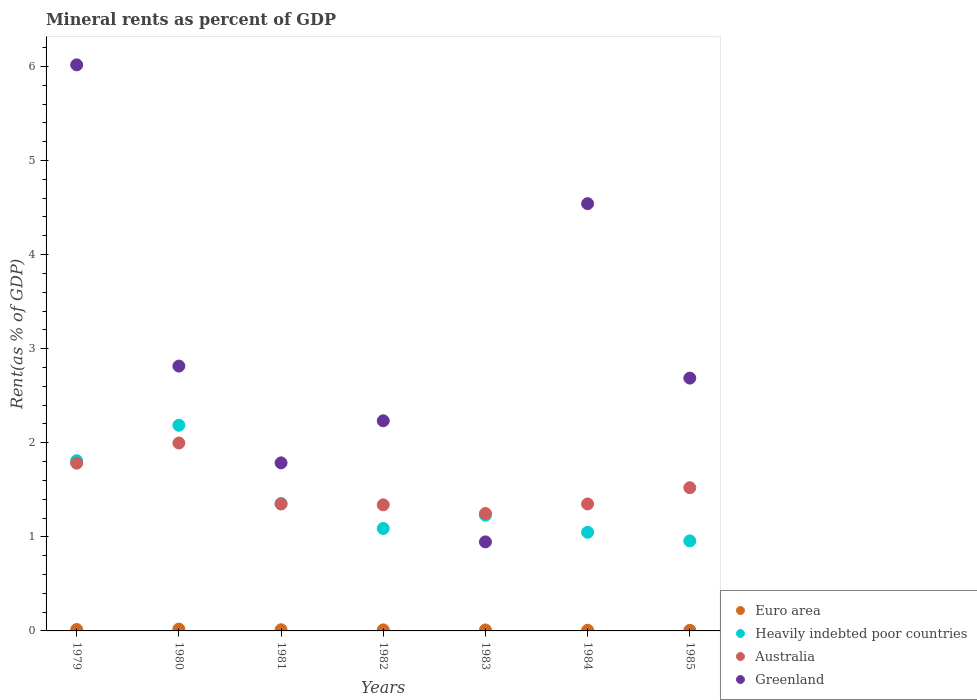How many different coloured dotlines are there?
Your answer should be very brief. 4. What is the mineral rent in Heavily indebted poor countries in 1983?
Your answer should be very brief. 1.23. Across all years, what is the maximum mineral rent in Greenland?
Offer a very short reply. 6.02. Across all years, what is the minimum mineral rent in Australia?
Make the answer very short. 1.25. In which year was the mineral rent in Australia maximum?
Make the answer very short. 1980. In which year was the mineral rent in Australia minimum?
Provide a short and direct response. 1983. What is the total mineral rent in Euro area in the graph?
Offer a very short reply. 0.08. What is the difference between the mineral rent in Heavily indebted poor countries in 1982 and that in 1985?
Ensure brevity in your answer.  0.13. What is the difference between the mineral rent in Greenland in 1983 and the mineral rent in Australia in 1980?
Offer a very short reply. -1.05. What is the average mineral rent in Heavily indebted poor countries per year?
Offer a very short reply. 1.38. In the year 1983, what is the difference between the mineral rent in Heavily indebted poor countries and mineral rent in Euro area?
Offer a very short reply. 1.22. In how many years, is the mineral rent in Heavily indebted poor countries greater than 5.4 %?
Provide a short and direct response. 0. What is the ratio of the mineral rent in Euro area in 1979 to that in 1981?
Offer a very short reply. 1.25. Is the difference between the mineral rent in Heavily indebted poor countries in 1984 and 1985 greater than the difference between the mineral rent in Euro area in 1984 and 1985?
Give a very brief answer. Yes. What is the difference between the highest and the second highest mineral rent in Greenland?
Offer a very short reply. 1.48. What is the difference between the highest and the lowest mineral rent in Australia?
Give a very brief answer. 0.75. In how many years, is the mineral rent in Australia greater than the average mineral rent in Australia taken over all years?
Keep it short and to the point. 3. Is it the case that in every year, the sum of the mineral rent in Australia and mineral rent in Greenland  is greater than the sum of mineral rent in Heavily indebted poor countries and mineral rent in Euro area?
Provide a short and direct response. Yes. Is it the case that in every year, the sum of the mineral rent in Australia and mineral rent in Euro area  is greater than the mineral rent in Greenland?
Make the answer very short. No. Is the mineral rent in Australia strictly greater than the mineral rent in Euro area over the years?
Provide a succinct answer. Yes. How many years are there in the graph?
Offer a terse response. 7. What is the difference between two consecutive major ticks on the Y-axis?
Your answer should be compact. 1. Does the graph contain any zero values?
Ensure brevity in your answer.  No. What is the title of the graph?
Provide a succinct answer. Mineral rents as percent of GDP. What is the label or title of the Y-axis?
Offer a very short reply. Rent(as % of GDP). What is the Rent(as % of GDP) in Euro area in 1979?
Your response must be concise. 0.02. What is the Rent(as % of GDP) in Heavily indebted poor countries in 1979?
Ensure brevity in your answer.  1.81. What is the Rent(as % of GDP) in Australia in 1979?
Your answer should be compact. 1.78. What is the Rent(as % of GDP) in Greenland in 1979?
Offer a very short reply. 6.02. What is the Rent(as % of GDP) in Euro area in 1980?
Provide a short and direct response. 0.02. What is the Rent(as % of GDP) in Heavily indebted poor countries in 1980?
Offer a very short reply. 2.19. What is the Rent(as % of GDP) of Australia in 1980?
Offer a terse response. 2. What is the Rent(as % of GDP) in Greenland in 1980?
Provide a succinct answer. 2.81. What is the Rent(as % of GDP) of Euro area in 1981?
Give a very brief answer. 0.01. What is the Rent(as % of GDP) in Heavily indebted poor countries in 1981?
Provide a short and direct response. 1.35. What is the Rent(as % of GDP) in Australia in 1981?
Provide a short and direct response. 1.35. What is the Rent(as % of GDP) in Greenland in 1981?
Your answer should be very brief. 1.79. What is the Rent(as % of GDP) of Euro area in 1982?
Your answer should be compact. 0.01. What is the Rent(as % of GDP) of Heavily indebted poor countries in 1982?
Your response must be concise. 1.09. What is the Rent(as % of GDP) in Australia in 1982?
Your answer should be very brief. 1.34. What is the Rent(as % of GDP) of Greenland in 1982?
Keep it short and to the point. 2.23. What is the Rent(as % of GDP) of Euro area in 1983?
Your answer should be compact. 0.01. What is the Rent(as % of GDP) in Heavily indebted poor countries in 1983?
Provide a succinct answer. 1.23. What is the Rent(as % of GDP) in Australia in 1983?
Make the answer very short. 1.25. What is the Rent(as % of GDP) of Greenland in 1983?
Offer a terse response. 0.95. What is the Rent(as % of GDP) of Euro area in 1984?
Give a very brief answer. 0.01. What is the Rent(as % of GDP) of Heavily indebted poor countries in 1984?
Make the answer very short. 1.05. What is the Rent(as % of GDP) of Australia in 1984?
Your answer should be compact. 1.35. What is the Rent(as % of GDP) in Greenland in 1984?
Your answer should be compact. 4.54. What is the Rent(as % of GDP) of Euro area in 1985?
Make the answer very short. 0.01. What is the Rent(as % of GDP) of Heavily indebted poor countries in 1985?
Your answer should be compact. 0.96. What is the Rent(as % of GDP) of Australia in 1985?
Make the answer very short. 1.52. What is the Rent(as % of GDP) in Greenland in 1985?
Provide a short and direct response. 2.69. Across all years, what is the maximum Rent(as % of GDP) of Euro area?
Give a very brief answer. 0.02. Across all years, what is the maximum Rent(as % of GDP) in Heavily indebted poor countries?
Make the answer very short. 2.19. Across all years, what is the maximum Rent(as % of GDP) of Australia?
Give a very brief answer. 2. Across all years, what is the maximum Rent(as % of GDP) in Greenland?
Offer a very short reply. 6.02. Across all years, what is the minimum Rent(as % of GDP) in Euro area?
Provide a short and direct response. 0.01. Across all years, what is the minimum Rent(as % of GDP) in Heavily indebted poor countries?
Offer a very short reply. 0.96. Across all years, what is the minimum Rent(as % of GDP) of Australia?
Your answer should be very brief. 1.25. Across all years, what is the minimum Rent(as % of GDP) in Greenland?
Your response must be concise. 0.95. What is the total Rent(as % of GDP) in Euro area in the graph?
Keep it short and to the point. 0.08. What is the total Rent(as % of GDP) in Heavily indebted poor countries in the graph?
Your answer should be compact. 9.67. What is the total Rent(as % of GDP) in Australia in the graph?
Your answer should be compact. 10.59. What is the total Rent(as % of GDP) of Greenland in the graph?
Make the answer very short. 21.03. What is the difference between the Rent(as % of GDP) in Euro area in 1979 and that in 1980?
Offer a terse response. -0. What is the difference between the Rent(as % of GDP) of Heavily indebted poor countries in 1979 and that in 1980?
Offer a very short reply. -0.38. What is the difference between the Rent(as % of GDP) in Australia in 1979 and that in 1980?
Your answer should be very brief. -0.21. What is the difference between the Rent(as % of GDP) in Greenland in 1979 and that in 1980?
Your answer should be compact. 3.2. What is the difference between the Rent(as % of GDP) in Euro area in 1979 and that in 1981?
Your answer should be very brief. 0. What is the difference between the Rent(as % of GDP) in Heavily indebted poor countries in 1979 and that in 1981?
Offer a very short reply. 0.46. What is the difference between the Rent(as % of GDP) of Australia in 1979 and that in 1981?
Offer a terse response. 0.43. What is the difference between the Rent(as % of GDP) in Greenland in 1979 and that in 1981?
Provide a short and direct response. 4.23. What is the difference between the Rent(as % of GDP) of Euro area in 1979 and that in 1982?
Ensure brevity in your answer.  0. What is the difference between the Rent(as % of GDP) in Heavily indebted poor countries in 1979 and that in 1982?
Keep it short and to the point. 0.72. What is the difference between the Rent(as % of GDP) in Australia in 1979 and that in 1982?
Offer a terse response. 0.44. What is the difference between the Rent(as % of GDP) in Greenland in 1979 and that in 1982?
Provide a succinct answer. 3.78. What is the difference between the Rent(as % of GDP) of Euro area in 1979 and that in 1983?
Offer a very short reply. 0.01. What is the difference between the Rent(as % of GDP) in Heavily indebted poor countries in 1979 and that in 1983?
Offer a terse response. 0.58. What is the difference between the Rent(as % of GDP) in Australia in 1979 and that in 1983?
Provide a short and direct response. 0.53. What is the difference between the Rent(as % of GDP) of Greenland in 1979 and that in 1983?
Give a very brief answer. 5.07. What is the difference between the Rent(as % of GDP) of Euro area in 1979 and that in 1984?
Make the answer very short. 0.01. What is the difference between the Rent(as % of GDP) of Heavily indebted poor countries in 1979 and that in 1984?
Your answer should be very brief. 0.76. What is the difference between the Rent(as % of GDP) in Australia in 1979 and that in 1984?
Provide a succinct answer. 0.43. What is the difference between the Rent(as % of GDP) of Greenland in 1979 and that in 1984?
Provide a short and direct response. 1.48. What is the difference between the Rent(as % of GDP) in Euro area in 1979 and that in 1985?
Provide a short and direct response. 0.01. What is the difference between the Rent(as % of GDP) of Heavily indebted poor countries in 1979 and that in 1985?
Your answer should be very brief. 0.85. What is the difference between the Rent(as % of GDP) of Australia in 1979 and that in 1985?
Offer a terse response. 0.26. What is the difference between the Rent(as % of GDP) of Greenland in 1979 and that in 1985?
Your response must be concise. 3.33. What is the difference between the Rent(as % of GDP) of Euro area in 1980 and that in 1981?
Ensure brevity in your answer.  0.01. What is the difference between the Rent(as % of GDP) in Heavily indebted poor countries in 1980 and that in 1981?
Make the answer very short. 0.83. What is the difference between the Rent(as % of GDP) in Australia in 1980 and that in 1981?
Keep it short and to the point. 0.65. What is the difference between the Rent(as % of GDP) in Greenland in 1980 and that in 1981?
Make the answer very short. 1.03. What is the difference between the Rent(as % of GDP) of Euro area in 1980 and that in 1982?
Give a very brief answer. 0.01. What is the difference between the Rent(as % of GDP) in Heavily indebted poor countries in 1980 and that in 1982?
Ensure brevity in your answer.  1.1. What is the difference between the Rent(as % of GDP) in Australia in 1980 and that in 1982?
Offer a very short reply. 0.66. What is the difference between the Rent(as % of GDP) of Greenland in 1980 and that in 1982?
Your answer should be compact. 0.58. What is the difference between the Rent(as % of GDP) of Euro area in 1980 and that in 1983?
Your answer should be very brief. 0.01. What is the difference between the Rent(as % of GDP) in Heavily indebted poor countries in 1980 and that in 1983?
Keep it short and to the point. 0.96. What is the difference between the Rent(as % of GDP) of Australia in 1980 and that in 1983?
Your answer should be very brief. 0.75. What is the difference between the Rent(as % of GDP) of Greenland in 1980 and that in 1983?
Keep it short and to the point. 1.87. What is the difference between the Rent(as % of GDP) of Euro area in 1980 and that in 1984?
Offer a terse response. 0.01. What is the difference between the Rent(as % of GDP) of Heavily indebted poor countries in 1980 and that in 1984?
Ensure brevity in your answer.  1.14. What is the difference between the Rent(as % of GDP) in Australia in 1980 and that in 1984?
Your response must be concise. 0.65. What is the difference between the Rent(as % of GDP) in Greenland in 1980 and that in 1984?
Provide a short and direct response. -1.73. What is the difference between the Rent(as % of GDP) of Euro area in 1980 and that in 1985?
Provide a short and direct response. 0.01. What is the difference between the Rent(as % of GDP) in Heavily indebted poor countries in 1980 and that in 1985?
Provide a succinct answer. 1.23. What is the difference between the Rent(as % of GDP) in Australia in 1980 and that in 1985?
Offer a terse response. 0.47. What is the difference between the Rent(as % of GDP) in Greenland in 1980 and that in 1985?
Give a very brief answer. 0.13. What is the difference between the Rent(as % of GDP) in Euro area in 1981 and that in 1982?
Keep it short and to the point. 0. What is the difference between the Rent(as % of GDP) in Heavily indebted poor countries in 1981 and that in 1982?
Your response must be concise. 0.26. What is the difference between the Rent(as % of GDP) in Australia in 1981 and that in 1982?
Ensure brevity in your answer.  0.01. What is the difference between the Rent(as % of GDP) in Greenland in 1981 and that in 1982?
Your answer should be compact. -0.45. What is the difference between the Rent(as % of GDP) in Euro area in 1981 and that in 1983?
Your response must be concise. 0. What is the difference between the Rent(as % of GDP) of Heavily indebted poor countries in 1981 and that in 1983?
Provide a succinct answer. 0.12. What is the difference between the Rent(as % of GDP) in Australia in 1981 and that in 1983?
Provide a succinct answer. 0.1. What is the difference between the Rent(as % of GDP) of Greenland in 1981 and that in 1983?
Ensure brevity in your answer.  0.84. What is the difference between the Rent(as % of GDP) in Euro area in 1981 and that in 1984?
Ensure brevity in your answer.  0.01. What is the difference between the Rent(as % of GDP) in Heavily indebted poor countries in 1981 and that in 1984?
Offer a terse response. 0.31. What is the difference between the Rent(as % of GDP) in Australia in 1981 and that in 1984?
Provide a short and direct response. -0. What is the difference between the Rent(as % of GDP) in Greenland in 1981 and that in 1984?
Offer a terse response. -2.75. What is the difference between the Rent(as % of GDP) in Euro area in 1981 and that in 1985?
Provide a short and direct response. 0.01. What is the difference between the Rent(as % of GDP) of Heavily indebted poor countries in 1981 and that in 1985?
Ensure brevity in your answer.  0.4. What is the difference between the Rent(as % of GDP) of Australia in 1981 and that in 1985?
Offer a very short reply. -0.17. What is the difference between the Rent(as % of GDP) of Greenland in 1981 and that in 1985?
Offer a very short reply. -0.9. What is the difference between the Rent(as % of GDP) in Euro area in 1982 and that in 1983?
Your response must be concise. 0. What is the difference between the Rent(as % of GDP) in Heavily indebted poor countries in 1982 and that in 1983?
Your response must be concise. -0.14. What is the difference between the Rent(as % of GDP) in Australia in 1982 and that in 1983?
Offer a very short reply. 0.09. What is the difference between the Rent(as % of GDP) of Greenland in 1982 and that in 1983?
Ensure brevity in your answer.  1.29. What is the difference between the Rent(as % of GDP) of Euro area in 1982 and that in 1984?
Your answer should be very brief. 0. What is the difference between the Rent(as % of GDP) of Heavily indebted poor countries in 1982 and that in 1984?
Make the answer very short. 0.04. What is the difference between the Rent(as % of GDP) of Australia in 1982 and that in 1984?
Keep it short and to the point. -0.01. What is the difference between the Rent(as % of GDP) of Greenland in 1982 and that in 1984?
Make the answer very short. -2.31. What is the difference between the Rent(as % of GDP) in Euro area in 1982 and that in 1985?
Keep it short and to the point. 0.01. What is the difference between the Rent(as % of GDP) of Heavily indebted poor countries in 1982 and that in 1985?
Your answer should be very brief. 0.13. What is the difference between the Rent(as % of GDP) of Australia in 1982 and that in 1985?
Give a very brief answer. -0.18. What is the difference between the Rent(as % of GDP) of Greenland in 1982 and that in 1985?
Offer a very short reply. -0.45. What is the difference between the Rent(as % of GDP) of Euro area in 1983 and that in 1984?
Keep it short and to the point. 0. What is the difference between the Rent(as % of GDP) of Heavily indebted poor countries in 1983 and that in 1984?
Your answer should be very brief. 0.18. What is the difference between the Rent(as % of GDP) of Australia in 1983 and that in 1984?
Your response must be concise. -0.1. What is the difference between the Rent(as % of GDP) of Greenland in 1983 and that in 1984?
Offer a terse response. -3.6. What is the difference between the Rent(as % of GDP) in Euro area in 1983 and that in 1985?
Your answer should be very brief. 0. What is the difference between the Rent(as % of GDP) in Heavily indebted poor countries in 1983 and that in 1985?
Offer a terse response. 0.27. What is the difference between the Rent(as % of GDP) in Australia in 1983 and that in 1985?
Ensure brevity in your answer.  -0.27. What is the difference between the Rent(as % of GDP) in Greenland in 1983 and that in 1985?
Make the answer very short. -1.74. What is the difference between the Rent(as % of GDP) of Euro area in 1984 and that in 1985?
Keep it short and to the point. 0. What is the difference between the Rent(as % of GDP) in Heavily indebted poor countries in 1984 and that in 1985?
Your answer should be very brief. 0.09. What is the difference between the Rent(as % of GDP) of Australia in 1984 and that in 1985?
Offer a very short reply. -0.17. What is the difference between the Rent(as % of GDP) of Greenland in 1984 and that in 1985?
Your answer should be compact. 1.85. What is the difference between the Rent(as % of GDP) of Euro area in 1979 and the Rent(as % of GDP) of Heavily indebted poor countries in 1980?
Offer a terse response. -2.17. What is the difference between the Rent(as % of GDP) in Euro area in 1979 and the Rent(as % of GDP) in Australia in 1980?
Ensure brevity in your answer.  -1.98. What is the difference between the Rent(as % of GDP) in Euro area in 1979 and the Rent(as % of GDP) in Greenland in 1980?
Give a very brief answer. -2.8. What is the difference between the Rent(as % of GDP) in Heavily indebted poor countries in 1979 and the Rent(as % of GDP) in Australia in 1980?
Make the answer very short. -0.19. What is the difference between the Rent(as % of GDP) in Heavily indebted poor countries in 1979 and the Rent(as % of GDP) in Greenland in 1980?
Make the answer very short. -1.01. What is the difference between the Rent(as % of GDP) of Australia in 1979 and the Rent(as % of GDP) of Greenland in 1980?
Ensure brevity in your answer.  -1.03. What is the difference between the Rent(as % of GDP) of Euro area in 1979 and the Rent(as % of GDP) of Heavily indebted poor countries in 1981?
Offer a very short reply. -1.34. What is the difference between the Rent(as % of GDP) in Euro area in 1979 and the Rent(as % of GDP) in Australia in 1981?
Offer a very short reply. -1.33. What is the difference between the Rent(as % of GDP) of Euro area in 1979 and the Rent(as % of GDP) of Greenland in 1981?
Keep it short and to the point. -1.77. What is the difference between the Rent(as % of GDP) in Heavily indebted poor countries in 1979 and the Rent(as % of GDP) in Australia in 1981?
Offer a terse response. 0.46. What is the difference between the Rent(as % of GDP) of Heavily indebted poor countries in 1979 and the Rent(as % of GDP) of Greenland in 1981?
Keep it short and to the point. 0.02. What is the difference between the Rent(as % of GDP) in Australia in 1979 and the Rent(as % of GDP) in Greenland in 1981?
Offer a terse response. -0. What is the difference between the Rent(as % of GDP) of Euro area in 1979 and the Rent(as % of GDP) of Heavily indebted poor countries in 1982?
Provide a short and direct response. -1.07. What is the difference between the Rent(as % of GDP) in Euro area in 1979 and the Rent(as % of GDP) in Australia in 1982?
Your response must be concise. -1.32. What is the difference between the Rent(as % of GDP) of Euro area in 1979 and the Rent(as % of GDP) of Greenland in 1982?
Provide a short and direct response. -2.22. What is the difference between the Rent(as % of GDP) of Heavily indebted poor countries in 1979 and the Rent(as % of GDP) of Australia in 1982?
Ensure brevity in your answer.  0.47. What is the difference between the Rent(as % of GDP) of Heavily indebted poor countries in 1979 and the Rent(as % of GDP) of Greenland in 1982?
Ensure brevity in your answer.  -0.42. What is the difference between the Rent(as % of GDP) of Australia in 1979 and the Rent(as % of GDP) of Greenland in 1982?
Your answer should be very brief. -0.45. What is the difference between the Rent(as % of GDP) in Euro area in 1979 and the Rent(as % of GDP) in Heavily indebted poor countries in 1983?
Offer a very short reply. -1.21. What is the difference between the Rent(as % of GDP) in Euro area in 1979 and the Rent(as % of GDP) in Australia in 1983?
Your response must be concise. -1.23. What is the difference between the Rent(as % of GDP) of Euro area in 1979 and the Rent(as % of GDP) of Greenland in 1983?
Make the answer very short. -0.93. What is the difference between the Rent(as % of GDP) of Heavily indebted poor countries in 1979 and the Rent(as % of GDP) of Australia in 1983?
Offer a terse response. 0.56. What is the difference between the Rent(as % of GDP) of Heavily indebted poor countries in 1979 and the Rent(as % of GDP) of Greenland in 1983?
Provide a succinct answer. 0.86. What is the difference between the Rent(as % of GDP) in Australia in 1979 and the Rent(as % of GDP) in Greenland in 1983?
Ensure brevity in your answer.  0.84. What is the difference between the Rent(as % of GDP) in Euro area in 1979 and the Rent(as % of GDP) in Heavily indebted poor countries in 1984?
Provide a succinct answer. -1.03. What is the difference between the Rent(as % of GDP) of Euro area in 1979 and the Rent(as % of GDP) of Australia in 1984?
Keep it short and to the point. -1.33. What is the difference between the Rent(as % of GDP) of Euro area in 1979 and the Rent(as % of GDP) of Greenland in 1984?
Provide a succinct answer. -4.53. What is the difference between the Rent(as % of GDP) of Heavily indebted poor countries in 1979 and the Rent(as % of GDP) of Australia in 1984?
Provide a short and direct response. 0.46. What is the difference between the Rent(as % of GDP) in Heavily indebted poor countries in 1979 and the Rent(as % of GDP) in Greenland in 1984?
Provide a short and direct response. -2.73. What is the difference between the Rent(as % of GDP) in Australia in 1979 and the Rent(as % of GDP) in Greenland in 1984?
Keep it short and to the point. -2.76. What is the difference between the Rent(as % of GDP) of Euro area in 1979 and the Rent(as % of GDP) of Heavily indebted poor countries in 1985?
Your response must be concise. -0.94. What is the difference between the Rent(as % of GDP) in Euro area in 1979 and the Rent(as % of GDP) in Australia in 1985?
Give a very brief answer. -1.51. What is the difference between the Rent(as % of GDP) of Euro area in 1979 and the Rent(as % of GDP) of Greenland in 1985?
Provide a succinct answer. -2.67. What is the difference between the Rent(as % of GDP) of Heavily indebted poor countries in 1979 and the Rent(as % of GDP) of Australia in 1985?
Your response must be concise. 0.29. What is the difference between the Rent(as % of GDP) in Heavily indebted poor countries in 1979 and the Rent(as % of GDP) in Greenland in 1985?
Your response must be concise. -0.88. What is the difference between the Rent(as % of GDP) in Australia in 1979 and the Rent(as % of GDP) in Greenland in 1985?
Keep it short and to the point. -0.9. What is the difference between the Rent(as % of GDP) of Euro area in 1980 and the Rent(as % of GDP) of Heavily indebted poor countries in 1981?
Make the answer very short. -1.33. What is the difference between the Rent(as % of GDP) in Euro area in 1980 and the Rent(as % of GDP) in Australia in 1981?
Offer a terse response. -1.33. What is the difference between the Rent(as % of GDP) of Euro area in 1980 and the Rent(as % of GDP) of Greenland in 1981?
Your answer should be compact. -1.77. What is the difference between the Rent(as % of GDP) of Heavily indebted poor countries in 1980 and the Rent(as % of GDP) of Australia in 1981?
Keep it short and to the point. 0.84. What is the difference between the Rent(as % of GDP) in Heavily indebted poor countries in 1980 and the Rent(as % of GDP) in Greenland in 1981?
Offer a very short reply. 0.4. What is the difference between the Rent(as % of GDP) of Australia in 1980 and the Rent(as % of GDP) of Greenland in 1981?
Your answer should be very brief. 0.21. What is the difference between the Rent(as % of GDP) in Euro area in 1980 and the Rent(as % of GDP) in Heavily indebted poor countries in 1982?
Make the answer very short. -1.07. What is the difference between the Rent(as % of GDP) of Euro area in 1980 and the Rent(as % of GDP) of Australia in 1982?
Your answer should be very brief. -1.32. What is the difference between the Rent(as % of GDP) in Euro area in 1980 and the Rent(as % of GDP) in Greenland in 1982?
Provide a succinct answer. -2.21. What is the difference between the Rent(as % of GDP) in Heavily indebted poor countries in 1980 and the Rent(as % of GDP) in Australia in 1982?
Your answer should be compact. 0.85. What is the difference between the Rent(as % of GDP) of Heavily indebted poor countries in 1980 and the Rent(as % of GDP) of Greenland in 1982?
Your answer should be very brief. -0.05. What is the difference between the Rent(as % of GDP) in Australia in 1980 and the Rent(as % of GDP) in Greenland in 1982?
Offer a terse response. -0.24. What is the difference between the Rent(as % of GDP) in Euro area in 1980 and the Rent(as % of GDP) in Heavily indebted poor countries in 1983?
Offer a very short reply. -1.21. What is the difference between the Rent(as % of GDP) of Euro area in 1980 and the Rent(as % of GDP) of Australia in 1983?
Make the answer very short. -1.23. What is the difference between the Rent(as % of GDP) in Euro area in 1980 and the Rent(as % of GDP) in Greenland in 1983?
Offer a very short reply. -0.93. What is the difference between the Rent(as % of GDP) in Heavily indebted poor countries in 1980 and the Rent(as % of GDP) in Australia in 1983?
Provide a succinct answer. 0.94. What is the difference between the Rent(as % of GDP) of Heavily indebted poor countries in 1980 and the Rent(as % of GDP) of Greenland in 1983?
Make the answer very short. 1.24. What is the difference between the Rent(as % of GDP) of Australia in 1980 and the Rent(as % of GDP) of Greenland in 1983?
Your response must be concise. 1.05. What is the difference between the Rent(as % of GDP) in Euro area in 1980 and the Rent(as % of GDP) in Heavily indebted poor countries in 1984?
Make the answer very short. -1.03. What is the difference between the Rent(as % of GDP) of Euro area in 1980 and the Rent(as % of GDP) of Australia in 1984?
Your response must be concise. -1.33. What is the difference between the Rent(as % of GDP) in Euro area in 1980 and the Rent(as % of GDP) in Greenland in 1984?
Keep it short and to the point. -4.52. What is the difference between the Rent(as % of GDP) of Heavily indebted poor countries in 1980 and the Rent(as % of GDP) of Australia in 1984?
Your answer should be very brief. 0.84. What is the difference between the Rent(as % of GDP) in Heavily indebted poor countries in 1980 and the Rent(as % of GDP) in Greenland in 1984?
Give a very brief answer. -2.36. What is the difference between the Rent(as % of GDP) in Australia in 1980 and the Rent(as % of GDP) in Greenland in 1984?
Your response must be concise. -2.54. What is the difference between the Rent(as % of GDP) in Euro area in 1980 and the Rent(as % of GDP) in Heavily indebted poor countries in 1985?
Your answer should be very brief. -0.94. What is the difference between the Rent(as % of GDP) of Euro area in 1980 and the Rent(as % of GDP) of Australia in 1985?
Give a very brief answer. -1.5. What is the difference between the Rent(as % of GDP) of Euro area in 1980 and the Rent(as % of GDP) of Greenland in 1985?
Your answer should be compact. -2.67. What is the difference between the Rent(as % of GDP) of Heavily indebted poor countries in 1980 and the Rent(as % of GDP) of Australia in 1985?
Your response must be concise. 0.66. What is the difference between the Rent(as % of GDP) of Heavily indebted poor countries in 1980 and the Rent(as % of GDP) of Greenland in 1985?
Provide a short and direct response. -0.5. What is the difference between the Rent(as % of GDP) in Australia in 1980 and the Rent(as % of GDP) in Greenland in 1985?
Offer a very short reply. -0.69. What is the difference between the Rent(as % of GDP) of Euro area in 1981 and the Rent(as % of GDP) of Heavily indebted poor countries in 1982?
Provide a succinct answer. -1.08. What is the difference between the Rent(as % of GDP) in Euro area in 1981 and the Rent(as % of GDP) in Australia in 1982?
Your answer should be compact. -1.33. What is the difference between the Rent(as % of GDP) in Euro area in 1981 and the Rent(as % of GDP) in Greenland in 1982?
Your response must be concise. -2.22. What is the difference between the Rent(as % of GDP) of Heavily indebted poor countries in 1981 and the Rent(as % of GDP) of Australia in 1982?
Make the answer very short. 0.01. What is the difference between the Rent(as % of GDP) of Heavily indebted poor countries in 1981 and the Rent(as % of GDP) of Greenland in 1982?
Offer a very short reply. -0.88. What is the difference between the Rent(as % of GDP) of Australia in 1981 and the Rent(as % of GDP) of Greenland in 1982?
Provide a succinct answer. -0.88. What is the difference between the Rent(as % of GDP) in Euro area in 1981 and the Rent(as % of GDP) in Heavily indebted poor countries in 1983?
Give a very brief answer. -1.22. What is the difference between the Rent(as % of GDP) of Euro area in 1981 and the Rent(as % of GDP) of Australia in 1983?
Offer a terse response. -1.24. What is the difference between the Rent(as % of GDP) of Euro area in 1981 and the Rent(as % of GDP) of Greenland in 1983?
Ensure brevity in your answer.  -0.93. What is the difference between the Rent(as % of GDP) of Heavily indebted poor countries in 1981 and the Rent(as % of GDP) of Australia in 1983?
Give a very brief answer. 0.11. What is the difference between the Rent(as % of GDP) of Heavily indebted poor countries in 1981 and the Rent(as % of GDP) of Greenland in 1983?
Give a very brief answer. 0.41. What is the difference between the Rent(as % of GDP) of Australia in 1981 and the Rent(as % of GDP) of Greenland in 1983?
Keep it short and to the point. 0.4. What is the difference between the Rent(as % of GDP) in Euro area in 1981 and the Rent(as % of GDP) in Heavily indebted poor countries in 1984?
Your answer should be very brief. -1.04. What is the difference between the Rent(as % of GDP) in Euro area in 1981 and the Rent(as % of GDP) in Australia in 1984?
Your answer should be compact. -1.34. What is the difference between the Rent(as % of GDP) in Euro area in 1981 and the Rent(as % of GDP) in Greenland in 1984?
Ensure brevity in your answer.  -4.53. What is the difference between the Rent(as % of GDP) in Heavily indebted poor countries in 1981 and the Rent(as % of GDP) in Australia in 1984?
Your response must be concise. 0. What is the difference between the Rent(as % of GDP) of Heavily indebted poor countries in 1981 and the Rent(as % of GDP) of Greenland in 1984?
Offer a terse response. -3.19. What is the difference between the Rent(as % of GDP) of Australia in 1981 and the Rent(as % of GDP) of Greenland in 1984?
Provide a short and direct response. -3.19. What is the difference between the Rent(as % of GDP) in Euro area in 1981 and the Rent(as % of GDP) in Heavily indebted poor countries in 1985?
Provide a short and direct response. -0.94. What is the difference between the Rent(as % of GDP) in Euro area in 1981 and the Rent(as % of GDP) in Australia in 1985?
Give a very brief answer. -1.51. What is the difference between the Rent(as % of GDP) in Euro area in 1981 and the Rent(as % of GDP) in Greenland in 1985?
Keep it short and to the point. -2.67. What is the difference between the Rent(as % of GDP) in Heavily indebted poor countries in 1981 and the Rent(as % of GDP) in Australia in 1985?
Give a very brief answer. -0.17. What is the difference between the Rent(as % of GDP) of Heavily indebted poor countries in 1981 and the Rent(as % of GDP) of Greenland in 1985?
Ensure brevity in your answer.  -1.33. What is the difference between the Rent(as % of GDP) of Australia in 1981 and the Rent(as % of GDP) of Greenland in 1985?
Your answer should be compact. -1.34. What is the difference between the Rent(as % of GDP) in Euro area in 1982 and the Rent(as % of GDP) in Heavily indebted poor countries in 1983?
Offer a very short reply. -1.22. What is the difference between the Rent(as % of GDP) in Euro area in 1982 and the Rent(as % of GDP) in Australia in 1983?
Give a very brief answer. -1.24. What is the difference between the Rent(as % of GDP) of Euro area in 1982 and the Rent(as % of GDP) of Greenland in 1983?
Your answer should be very brief. -0.94. What is the difference between the Rent(as % of GDP) of Heavily indebted poor countries in 1982 and the Rent(as % of GDP) of Australia in 1983?
Provide a short and direct response. -0.16. What is the difference between the Rent(as % of GDP) in Heavily indebted poor countries in 1982 and the Rent(as % of GDP) in Greenland in 1983?
Your answer should be very brief. 0.14. What is the difference between the Rent(as % of GDP) in Australia in 1982 and the Rent(as % of GDP) in Greenland in 1983?
Keep it short and to the point. 0.39. What is the difference between the Rent(as % of GDP) of Euro area in 1982 and the Rent(as % of GDP) of Heavily indebted poor countries in 1984?
Your response must be concise. -1.04. What is the difference between the Rent(as % of GDP) of Euro area in 1982 and the Rent(as % of GDP) of Australia in 1984?
Your answer should be very brief. -1.34. What is the difference between the Rent(as % of GDP) in Euro area in 1982 and the Rent(as % of GDP) in Greenland in 1984?
Your answer should be very brief. -4.53. What is the difference between the Rent(as % of GDP) of Heavily indebted poor countries in 1982 and the Rent(as % of GDP) of Australia in 1984?
Offer a terse response. -0.26. What is the difference between the Rent(as % of GDP) of Heavily indebted poor countries in 1982 and the Rent(as % of GDP) of Greenland in 1984?
Ensure brevity in your answer.  -3.45. What is the difference between the Rent(as % of GDP) in Australia in 1982 and the Rent(as % of GDP) in Greenland in 1984?
Make the answer very short. -3.2. What is the difference between the Rent(as % of GDP) in Euro area in 1982 and the Rent(as % of GDP) in Heavily indebted poor countries in 1985?
Your response must be concise. -0.95. What is the difference between the Rent(as % of GDP) in Euro area in 1982 and the Rent(as % of GDP) in Australia in 1985?
Keep it short and to the point. -1.51. What is the difference between the Rent(as % of GDP) of Euro area in 1982 and the Rent(as % of GDP) of Greenland in 1985?
Ensure brevity in your answer.  -2.68. What is the difference between the Rent(as % of GDP) of Heavily indebted poor countries in 1982 and the Rent(as % of GDP) of Australia in 1985?
Provide a short and direct response. -0.43. What is the difference between the Rent(as % of GDP) in Heavily indebted poor countries in 1982 and the Rent(as % of GDP) in Greenland in 1985?
Give a very brief answer. -1.6. What is the difference between the Rent(as % of GDP) in Australia in 1982 and the Rent(as % of GDP) in Greenland in 1985?
Ensure brevity in your answer.  -1.35. What is the difference between the Rent(as % of GDP) in Euro area in 1983 and the Rent(as % of GDP) in Heavily indebted poor countries in 1984?
Your answer should be very brief. -1.04. What is the difference between the Rent(as % of GDP) in Euro area in 1983 and the Rent(as % of GDP) in Australia in 1984?
Keep it short and to the point. -1.34. What is the difference between the Rent(as % of GDP) in Euro area in 1983 and the Rent(as % of GDP) in Greenland in 1984?
Your answer should be very brief. -4.53. What is the difference between the Rent(as % of GDP) in Heavily indebted poor countries in 1983 and the Rent(as % of GDP) in Australia in 1984?
Give a very brief answer. -0.12. What is the difference between the Rent(as % of GDP) in Heavily indebted poor countries in 1983 and the Rent(as % of GDP) in Greenland in 1984?
Offer a terse response. -3.31. What is the difference between the Rent(as % of GDP) in Australia in 1983 and the Rent(as % of GDP) in Greenland in 1984?
Keep it short and to the point. -3.29. What is the difference between the Rent(as % of GDP) of Euro area in 1983 and the Rent(as % of GDP) of Heavily indebted poor countries in 1985?
Provide a short and direct response. -0.95. What is the difference between the Rent(as % of GDP) of Euro area in 1983 and the Rent(as % of GDP) of Australia in 1985?
Your answer should be very brief. -1.51. What is the difference between the Rent(as % of GDP) in Euro area in 1983 and the Rent(as % of GDP) in Greenland in 1985?
Your answer should be very brief. -2.68. What is the difference between the Rent(as % of GDP) of Heavily indebted poor countries in 1983 and the Rent(as % of GDP) of Australia in 1985?
Your answer should be compact. -0.29. What is the difference between the Rent(as % of GDP) in Heavily indebted poor countries in 1983 and the Rent(as % of GDP) in Greenland in 1985?
Provide a succinct answer. -1.46. What is the difference between the Rent(as % of GDP) in Australia in 1983 and the Rent(as % of GDP) in Greenland in 1985?
Provide a short and direct response. -1.44. What is the difference between the Rent(as % of GDP) in Euro area in 1984 and the Rent(as % of GDP) in Heavily indebted poor countries in 1985?
Provide a short and direct response. -0.95. What is the difference between the Rent(as % of GDP) in Euro area in 1984 and the Rent(as % of GDP) in Australia in 1985?
Make the answer very short. -1.51. What is the difference between the Rent(as % of GDP) of Euro area in 1984 and the Rent(as % of GDP) of Greenland in 1985?
Provide a succinct answer. -2.68. What is the difference between the Rent(as % of GDP) of Heavily indebted poor countries in 1984 and the Rent(as % of GDP) of Australia in 1985?
Offer a very short reply. -0.47. What is the difference between the Rent(as % of GDP) of Heavily indebted poor countries in 1984 and the Rent(as % of GDP) of Greenland in 1985?
Your answer should be very brief. -1.64. What is the difference between the Rent(as % of GDP) in Australia in 1984 and the Rent(as % of GDP) in Greenland in 1985?
Make the answer very short. -1.34. What is the average Rent(as % of GDP) in Euro area per year?
Make the answer very short. 0.01. What is the average Rent(as % of GDP) in Heavily indebted poor countries per year?
Give a very brief answer. 1.38. What is the average Rent(as % of GDP) in Australia per year?
Your answer should be very brief. 1.51. What is the average Rent(as % of GDP) of Greenland per year?
Your answer should be very brief. 3. In the year 1979, what is the difference between the Rent(as % of GDP) of Euro area and Rent(as % of GDP) of Heavily indebted poor countries?
Your response must be concise. -1.79. In the year 1979, what is the difference between the Rent(as % of GDP) in Euro area and Rent(as % of GDP) in Australia?
Make the answer very short. -1.77. In the year 1979, what is the difference between the Rent(as % of GDP) in Euro area and Rent(as % of GDP) in Greenland?
Keep it short and to the point. -6. In the year 1979, what is the difference between the Rent(as % of GDP) in Heavily indebted poor countries and Rent(as % of GDP) in Australia?
Offer a very short reply. 0.03. In the year 1979, what is the difference between the Rent(as % of GDP) of Heavily indebted poor countries and Rent(as % of GDP) of Greenland?
Give a very brief answer. -4.21. In the year 1979, what is the difference between the Rent(as % of GDP) in Australia and Rent(as % of GDP) in Greenland?
Ensure brevity in your answer.  -4.23. In the year 1980, what is the difference between the Rent(as % of GDP) of Euro area and Rent(as % of GDP) of Heavily indebted poor countries?
Keep it short and to the point. -2.17. In the year 1980, what is the difference between the Rent(as % of GDP) of Euro area and Rent(as % of GDP) of Australia?
Keep it short and to the point. -1.98. In the year 1980, what is the difference between the Rent(as % of GDP) of Euro area and Rent(as % of GDP) of Greenland?
Your answer should be very brief. -2.79. In the year 1980, what is the difference between the Rent(as % of GDP) in Heavily indebted poor countries and Rent(as % of GDP) in Australia?
Offer a terse response. 0.19. In the year 1980, what is the difference between the Rent(as % of GDP) of Heavily indebted poor countries and Rent(as % of GDP) of Greenland?
Ensure brevity in your answer.  -0.63. In the year 1980, what is the difference between the Rent(as % of GDP) in Australia and Rent(as % of GDP) in Greenland?
Your response must be concise. -0.82. In the year 1981, what is the difference between the Rent(as % of GDP) of Euro area and Rent(as % of GDP) of Heavily indebted poor countries?
Make the answer very short. -1.34. In the year 1981, what is the difference between the Rent(as % of GDP) in Euro area and Rent(as % of GDP) in Australia?
Make the answer very short. -1.34. In the year 1981, what is the difference between the Rent(as % of GDP) of Euro area and Rent(as % of GDP) of Greenland?
Ensure brevity in your answer.  -1.77. In the year 1981, what is the difference between the Rent(as % of GDP) in Heavily indebted poor countries and Rent(as % of GDP) in Australia?
Your answer should be very brief. 0. In the year 1981, what is the difference between the Rent(as % of GDP) in Heavily indebted poor countries and Rent(as % of GDP) in Greenland?
Your response must be concise. -0.43. In the year 1981, what is the difference between the Rent(as % of GDP) of Australia and Rent(as % of GDP) of Greenland?
Your answer should be very brief. -0.44. In the year 1982, what is the difference between the Rent(as % of GDP) in Euro area and Rent(as % of GDP) in Heavily indebted poor countries?
Make the answer very short. -1.08. In the year 1982, what is the difference between the Rent(as % of GDP) of Euro area and Rent(as % of GDP) of Australia?
Provide a succinct answer. -1.33. In the year 1982, what is the difference between the Rent(as % of GDP) in Euro area and Rent(as % of GDP) in Greenland?
Give a very brief answer. -2.22. In the year 1982, what is the difference between the Rent(as % of GDP) in Heavily indebted poor countries and Rent(as % of GDP) in Australia?
Ensure brevity in your answer.  -0.25. In the year 1982, what is the difference between the Rent(as % of GDP) in Heavily indebted poor countries and Rent(as % of GDP) in Greenland?
Ensure brevity in your answer.  -1.14. In the year 1982, what is the difference between the Rent(as % of GDP) in Australia and Rent(as % of GDP) in Greenland?
Offer a very short reply. -0.89. In the year 1983, what is the difference between the Rent(as % of GDP) of Euro area and Rent(as % of GDP) of Heavily indebted poor countries?
Offer a terse response. -1.22. In the year 1983, what is the difference between the Rent(as % of GDP) of Euro area and Rent(as % of GDP) of Australia?
Your answer should be compact. -1.24. In the year 1983, what is the difference between the Rent(as % of GDP) in Euro area and Rent(as % of GDP) in Greenland?
Your answer should be compact. -0.94. In the year 1983, what is the difference between the Rent(as % of GDP) of Heavily indebted poor countries and Rent(as % of GDP) of Australia?
Give a very brief answer. -0.02. In the year 1983, what is the difference between the Rent(as % of GDP) in Heavily indebted poor countries and Rent(as % of GDP) in Greenland?
Make the answer very short. 0.28. In the year 1983, what is the difference between the Rent(as % of GDP) of Australia and Rent(as % of GDP) of Greenland?
Your answer should be very brief. 0.3. In the year 1984, what is the difference between the Rent(as % of GDP) in Euro area and Rent(as % of GDP) in Heavily indebted poor countries?
Ensure brevity in your answer.  -1.04. In the year 1984, what is the difference between the Rent(as % of GDP) of Euro area and Rent(as % of GDP) of Australia?
Offer a very short reply. -1.34. In the year 1984, what is the difference between the Rent(as % of GDP) of Euro area and Rent(as % of GDP) of Greenland?
Ensure brevity in your answer.  -4.53. In the year 1984, what is the difference between the Rent(as % of GDP) of Heavily indebted poor countries and Rent(as % of GDP) of Australia?
Provide a succinct answer. -0.3. In the year 1984, what is the difference between the Rent(as % of GDP) of Heavily indebted poor countries and Rent(as % of GDP) of Greenland?
Your answer should be compact. -3.49. In the year 1984, what is the difference between the Rent(as % of GDP) of Australia and Rent(as % of GDP) of Greenland?
Offer a terse response. -3.19. In the year 1985, what is the difference between the Rent(as % of GDP) of Euro area and Rent(as % of GDP) of Heavily indebted poor countries?
Your answer should be very brief. -0.95. In the year 1985, what is the difference between the Rent(as % of GDP) of Euro area and Rent(as % of GDP) of Australia?
Provide a succinct answer. -1.52. In the year 1985, what is the difference between the Rent(as % of GDP) of Euro area and Rent(as % of GDP) of Greenland?
Provide a short and direct response. -2.68. In the year 1985, what is the difference between the Rent(as % of GDP) of Heavily indebted poor countries and Rent(as % of GDP) of Australia?
Ensure brevity in your answer.  -0.57. In the year 1985, what is the difference between the Rent(as % of GDP) of Heavily indebted poor countries and Rent(as % of GDP) of Greenland?
Your answer should be very brief. -1.73. In the year 1985, what is the difference between the Rent(as % of GDP) in Australia and Rent(as % of GDP) in Greenland?
Ensure brevity in your answer.  -1.16. What is the ratio of the Rent(as % of GDP) of Euro area in 1979 to that in 1980?
Ensure brevity in your answer.  0.78. What is the ratio of the Rent(as % of GDP) of Heavily indebted poor countries in 1979 to that in 1980?
Provide a short and direct response. 0.83. What is the ratio of the Rent(as % of GDP) in Australia in 1979 to that in 1980?
Provide a short and direct response. 0.89. What is the ratio of the Rent(as % of GDP) in Greenland in 1979 to that in 1980?
Ensure brevity in your answer.  2.14. What is the ratio of the Rent(as % of GDP) in Euro area in 1979 to that in 1981?
Make the answer very short. 1.25. What is the ratio of the Rent(as % of GDP) of Heavily indebted poor countries in 1979 to that in 1981?
Your answer should be compact. 1.34. What is the ratio of the Rent(as % of GDP) in Australia in 1979 to that in 1981?
Offer a terse response. 1.32. What is the ratio of the Rent(as % of GDP) in Greenland in 1979 to that in 1981?
Keep it short and to the point. 3.37. What is the ratio of the Rent(as % of GDP) of Euro area in 1979 to that in 1982?
Your response must be concise. 1.38. What is the ratio of the Rent(as % of GDP) in Heavily indebted poor countries in 1979 to that in 1982?
Give a very brief answer. 1.66. What is the ratio of the Rent(as % of GDP) in Australia in 1979 to that in 1982?
Ensure brevity in your answer.  1.33. What is the ratio of the Rent(as % of GDP) in Greenland in 1979 to that in 1982?
Give a very brief answer. 2.69. What is the ratio of the Rent(as % of GDP) of Euro area in 1979 to that in 1983?
Keep it short and to the point. 1.49. What is the ratio of the Rent(as % of GDP) of Heavily indebted poor countries in 1979 to that in 1983?
Your answer should be compact. 1.47. What is the ratio of the Rent(as % of GDP) of Australia in 1979 to that in 1983?
Provide a short and direct response. 1.43. What is the ratio of the Rent(as % of GDP) in Greenland in 1979 to that in 1983?
Your answer should be very brief. 6.36. What is the ratio of the Rent(as % of GDP) in Euro area in 1979 to that in 1984?
Ensure brevity in your answer.  2.16. What is the ratio of the Rent(as % of GDP) of Heavily indebted poor countries in 1979 to that in 1984?
Provide a succinct answer. 1.73. What is the ratio of the Rent(as % of GDP) of Australia in 1979 to that in 1984?
Your response must be concise. 1.32. What is the ratio of the Rent(as % of GDP) of Greenland in 1979 to that in 1984?
Make the answer very short. 1.32. What is the ratio of the Rent(as % of GDP) of Euro area in 1979 to that in 1985?
Make the answer very short. 2.63. What is the ratio of the Rent(as % of GDP) of Heavily indebted poor countries in 1979 to that in 1985?
Your response must be concise. 1.89. What is the ratio of the Rent(as % of GDP) of Australia in 1979 to that in 1985?
Offer a very short reply. 1.17. What is the ratio of the Rent(as % of GDP) of Greenland in 1979 to that in 1985?
Provide a short and direct response. 2.24. What is the ratio of the Rent(as % of GDP) of Euro area in 1980 to that in 1981?
Provide a succinct answer. 1.61. What is the ratio of the Rent(as % of GDP) of Heavily indebted poor countries in 1980 to that in 1981?
Your answer should be very brief. 1.61. What is the ratio of the Rent(as % of GDP) in Australia in 1980 to that in 1981?
Your answer should be very brief. 1.48. What is the ratio of the Rent(as % of GDP) of Greenland in 1980 to that in 1981?
Your answer should be very brief. 1.58. What is the ratio of the Rent(as % of GDP) in Euro area in 1980 to that in 1982?
Provide a short and direct response. 1.78. What is the ratio of the Rent(as % of GDP) of Heavily indebted poor countries in 1980 to that in 1982?
Your answer should be compact. 2.01. What is the ratio of the Rent(as % of GDP) in Australia in 1980 to that in 1982?
Make the answer very short. 1.49. What is the ratio of the Rent(as % of GDP) in Greenland in 1980 to that in 1982?
Your response must be concise. 1.26. What is the ratio of the Rent(as % of GDP) in Euro area in 1980 to that in 1983?
Your answer should be very brief. 1.92. What is the ratio of the Rent(as % of GDP) in Heavily indebted poor countries in 1980 to that in 1983?
Your answer should be very brief. 1.78. What is the ratio of the Rent(as % of GDP) of Australia in 1980 to that in 1983?
Offer a very short reply. 1.6. What is the ratio of the Rent(as % of GDP) in Greenland in 1980 to that in 1983?
Provide a succinct answer. 2.97. What is the ratio of the Rent(as % of GDP) in Euro area in 1980 to that in 1984?
Ensure brevity in your answer.  2.78. What is the ratio of the Rent(as % of GDP) of Heavily indebted poor countries in 1980 to that in 1984?
Give a very brief answer. 2.08. What is the ratio of the Rent(as % of GDP) in Australia in 1980 to that in 1984?
Make the answer very short. 1.48. What is the ratio of the Rent(as % of GDP) in Greenland in 1980 to that in 1984?
Keep it short and to the point. 0.62. What is the ratio of the Rent(as % of GDP) of Euro area in 1980 to that in 1985?
Give a very brief answer. 3.39. What is the ratio of the Rent(as % of GDP) in Heavily indebted poor countries in 1980 to that in 1985?
Offer a terse response. 2.28. What is the ratio of the Rent(as % of GDP) of Australia in 1980 to that in 1985?
Make the answer very short. 1.31. What is the ratio of the Rent(as % of GDP) of Greenland in 1980 to that in 1985?
Ensure brevity in your answer.  1.05. What is the ratio of the Rent(as % of GDP) in Euro area in 1981 to that in 1982?
Provide a short and direct response. 1.1. What is the ratio of the Rent(as % of GDP) in Heavily indebted poor countries in 1981 to that in 1982?
Your answer should be very brief. 1.24. What is the ratio of the Rent(as % of GDP) in Australia in 1981 to that in 1982?
Your response must be concise. 1.01. What is the ratio of the Rent(as % of GDP) of Greenland in 1981 to that in 1982?
Your answer should be compact. 0.8. What is the ratio of the Rent(as % of GDP) of Euro area in 1981 to that in 1983?
Your answer should be compact. 1.19. What is the ratio of the Rent(as % of GDP) of Heavily indebted poor countries in 1981 to that in 1983?
Your answer should be very brief. 1.1. What is the ratio of the Rent(as % of GDP) of Australia in 1981 to that in 1983?
Provide a short and direct response. 1.08. What is the ratio of the Rent(as % of GDP) in Greenland in 1981 to that in 1983?
Ensure brevity in your answer.  1.89. What is the ratio of the Rent(as % of GDP) of Euro area in 1981 to that in 1984?
Your response must be concise. 1.72. What is the ratio of the Rent(as % of GDP) in Heavily indebted poor countries in 1981 to that in 1984?
Offer a very short reply. 1.29. What is the ratio of the Rent(as % of GDP) of Greenland in 1981 to that in 1984?
Your answer should be very brief. 0.39. What is the ratio of the Rent(as % of GDP) of Euro area in 1981 to that in 1985?
Make the answer very short. 2.1. What is the ratio of the Rent(as % of GDP) of Heavily indebted poor countries in 1981 to that in 1985?
Provide a short and direct response. 1.41. What is the ratio of the Rent(as % of GDP) in Australia in 1981 to that in 1985?
Make the answer very short. 0.89. What is the ratio of the Rent(as % of GDP) in Greenland in 1981 to that in 1985?
Your response must be concise. 0.66. What is the ratio of the Rent(as % of GDP) of Euro area in 1982 to that in 1983?
Provide a short and direct response. 1.08. What is the ratio of the Rent(as % of GDP) of Heavily indebted poor countries in 1982 to that in 1983?
Make the answer very short. 0.89. What is the ratio of the Rent(as % of GDP) in Australia in 1982 to that in 1983?
Keep it short and to the point. 1.07. What is the ratio of the Rent(as % of GDP) of Greenland in 1982 to that in 1983?
Make the answer very short. 2.36. What is the ratio of the Rent(as % of GDP) of Euro area in 1982 to that in 1984?
Offer a terse response. 1.56. What is the ratio of the Rent(as % of GDP) of Greenland in 1982 to that in 1984?
Your response must be concise. 0.49. What is the ratio of the Rent(as % of GDP) in Euro area in 1982 to that in 1985?
Your answer should be very brief. 1.9. What is the ratio of the Rent(as % of GDP) of Heavily indebted poor countries in 1982 to that in 1985?
Offer a terse response. 1.14. What is the ratio of the Rent(as % of GDP) in Australia in 1982 to that in 1985?
Give a very brief answer. 0.88. What is the ratio of the Rent(as % of GDP) in Greenland in 1982 to that in 1985?
Offer a very short reply. 0.83. What is the ratio of the Rent(as % of GDP) in Euro area in 1983 to that in 1984?
Ensure brevity in your answer.  1.45. What is the ratio of the Rent(as % of GDP) of Heavily indebted poor countries in 1983 to that in 1984?
Ensure brevity in your answer.  1.17. What is the ratio of the Rent(as % of GDP) of Australia in 1983 to that in 1984?
Your answer should be very brief. 0.93. What is the ratio of the Rent(as % of GDP) in Greenland in 1983 to that in 1984?
Your response must be concise. 0.21. What is the ratio of the Rent(as % of GDP) in Euro area in 1983 to that in 1985?
Provide a short and direct response. 1.77. What is the ratio of the Rent(as % of GDP) of Heavily indebted poor countries in 1983 to that in 1985?
Provide a succinct answer. 1.29. What is the ratio of the Rent(as % of GDP) in Australia in 1983 to that in 1985?
Ensure brevity in your answer.  0.82. What is the ratio of the Rent(as % of GDP) in Greenland in 1983 to that in 1985?
Your answer should be very brief. 0.35. What is the ratio of the Rent(as % of GDP) of Euro area in 1984 to that in 1985?
Provide a short and direct response. 1.22. What is the ratio of the Rent(as % of GDP) of Heavily indebted poor countries in 1984 to that in 1985?
Ensure brevity in your answer.  1.1. What is the ratio of the Rent(as % of GDP) in Australia in 1984 to that in 1985?
Ensure brevity in your answer.  0.89. What is the ratio of the Rent(as % of GDP) in Greenland in 1984 to that in 1985?
Provide a succinct answer. 1.69. What is the difference between the highest and the second highest Rent(as % of GDP) in Euro area?
Provide a succinct answer. 0. What is the difference between the highest and the second highest Rent(as % of GDP) in Heavily indebted poor countries?
Give a very brief answer. 0.38. What is the difference between the highest and the second highest Rent(as % of GDP) in Australia?
Your answer should be compact. 0.21. What is the difference between the highest and the second highest Rent(as % of GDP) of Greenland?
Keep it short and to the point. 1.48. What is the difference between the highest and the lowest Rent(as % of GDP) of Euro area?
Give a very brief answer. 0.01. What is the difference between the highest and the lowest Rent(as % of GDP) in Heavily indebted poor countries?
Provide a succinct answer. 1.23. What is the difference between the highest and the lowest Rent(as % of GDP) of Australia?
Offer a terse response. 0.75. What is the difference between the highest and the lowest Rent(as % of GDP) in Greenland?
Provide a short and direct response. 5.07. 